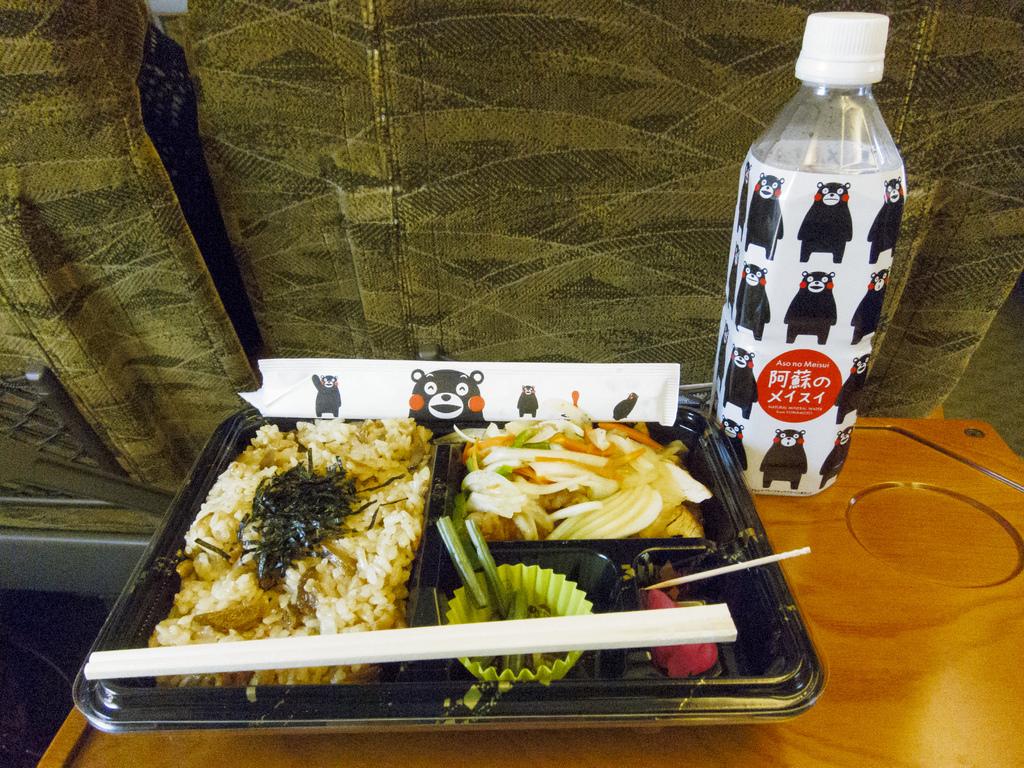Based pm the restaurant name on the wrapping is this in english?
Offer a terse response. No. 